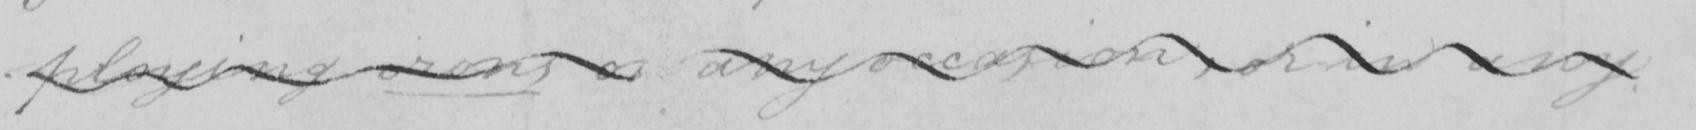Can you tell me what this handwritten text says? -ploying irons on any occasion , or in any 